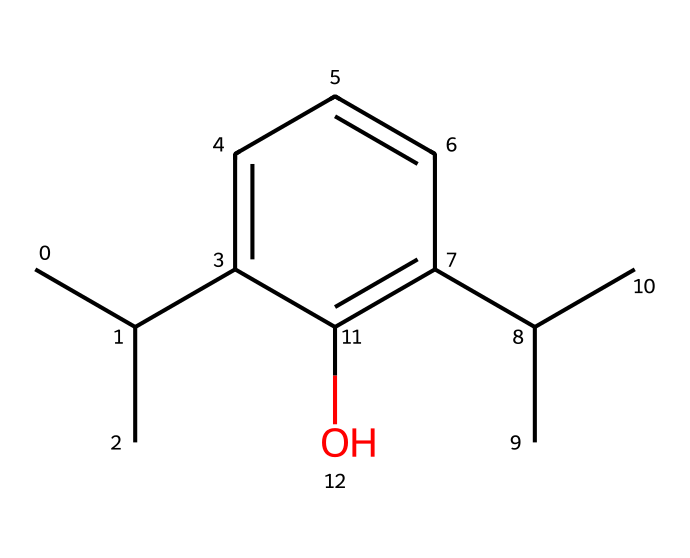What is the molecular formula of propofol? The SMILES representation helps us to identify the atoms present. Counting the carbon (C), hydrogen (H), and oxygen (O) atoms from the structure, we find that there are 12 carbon atoms, 18 hydrogen atoms, and 1 oxygen atom. Thus, the molecular formula is C12H18O.
Answer: C12H18O How many rings are present in the structure of propofol? Looking at the SMILES representation, we can see that there are no cyclic components indicated (such as numbers in the SMILES that represent ring closures). Therefore, the structure is acyclic with zero rings.
Answer: 0 What functional group is represented in the propofol's structure? The presence of an -OH (hydroxyl) group in the structure indicates that propofol has a phenol functional group. This can be identified directly from the functional oxygen bonded to a carbon atom within the benzene ring.
Answer: hydroxyl What is the total number of bond connections in propofol? In the SMILES notation, each atom is typically connected to others by bonds. By analyzing the arrangement and counting all single, double, and any implicit bonds, we conclude that there are 17 bonds connecting the atoms in the propofol molecule.
Answer: 17 Does propofol have any chiral centers, and if so, how many? Checking the structure for asymmetrical carbon atoms, we see that there are two carbons in the molecule that are attached to four different substituents, qualifying as chiral centers. Thus, the total number of chiral centers is 2.
Answer: 2 Why is propofol classified as a lipophilic compound? The presence of a long hydrocarbon chain alongside a relatively small polar functional group makes propofol more lipophilic. This means it has a tendency to dissolve in fats and oils, which is made evident by the overall structure composed predominantly of carbon atoms.
Answer: lipophilic 